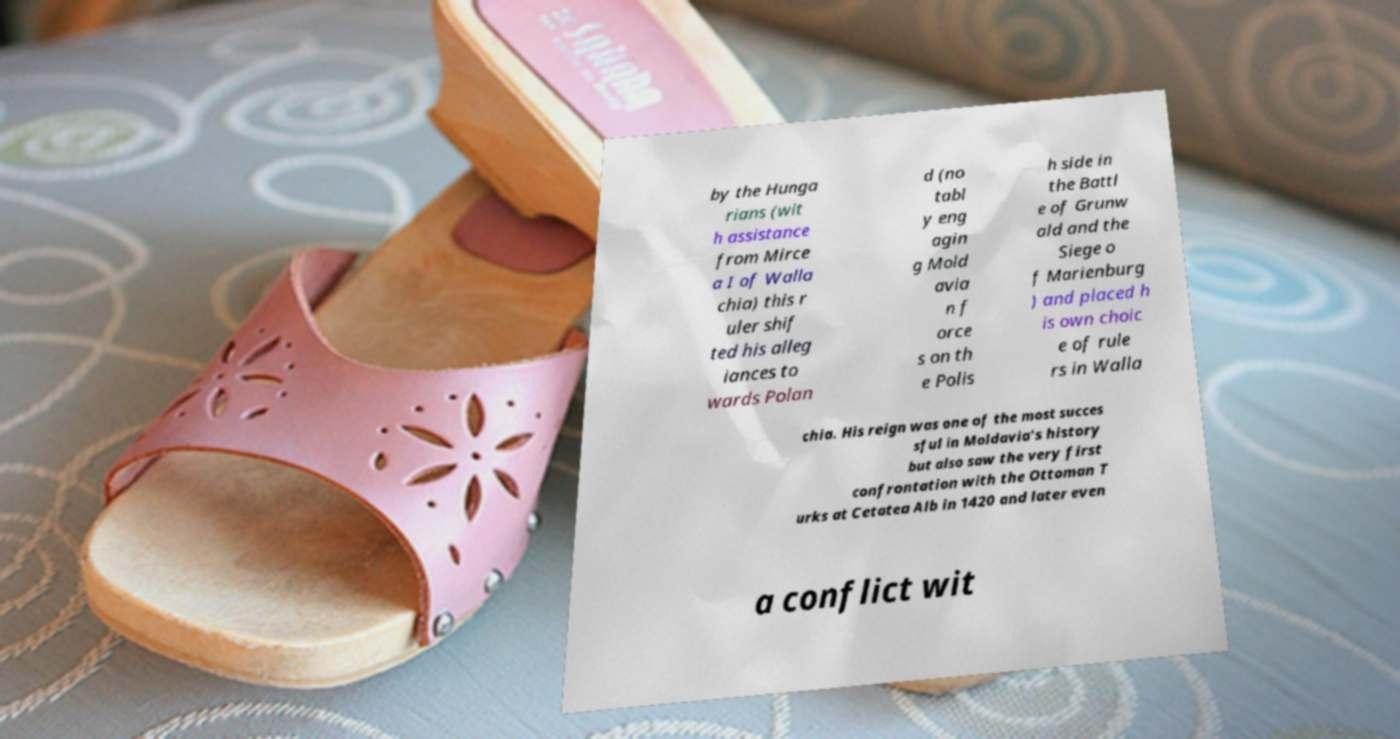Can you read and provide the text displayed in the image?This photo seems to have some interesting text. Can you extract and type it out for me? by the Hunga rians (wit h assistance from Mirce a I of Walla chia) this r uler shif ted his alleg iances to wards Polan d (no tabl y eng agin g Mold avia n f orce s on th e Polis h side in the Battl e of Grunw ald and the Siege o f Marienburg ) and placed h is own choic e of rule rs in Walla chia. His reign was one of the most succes sful in Moldavia's history but also saw the very first confrontation with the Ottoman T urks at Cetatea Alb in 1420 and later even a conflict wit 